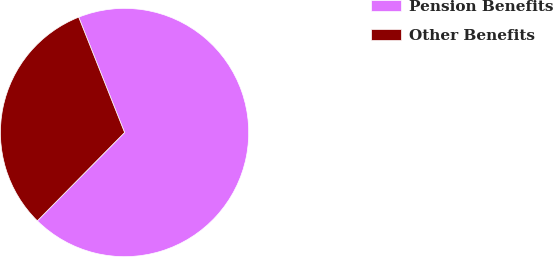<chart> <loc_0><loc_0><loc_500><loc_500><pie_chart><fcel>Pension Benefits<fcel>Other Benefits<nl><fcel>68.43%<fcel>31.57%<nl></chart> 